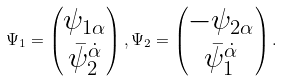<formula> <loc_0><loc_0><loc_500><loc_500>\Psi _ { 1 } = \left ( \begin{matrix} \psi _ { 1 \alpha } \\ \bar { \psi } _ { 2 } ^ { \dot { \alpha } } \end{matrix} \right ) , \Psi _ { 2 } = \left ( \begin{matrix} - \psi _ { 2 \alpha } \\ \bar { \psi } _ { 1 } ^ { \dot { \alpha } } \end{matrix} \right ) .</formula> 